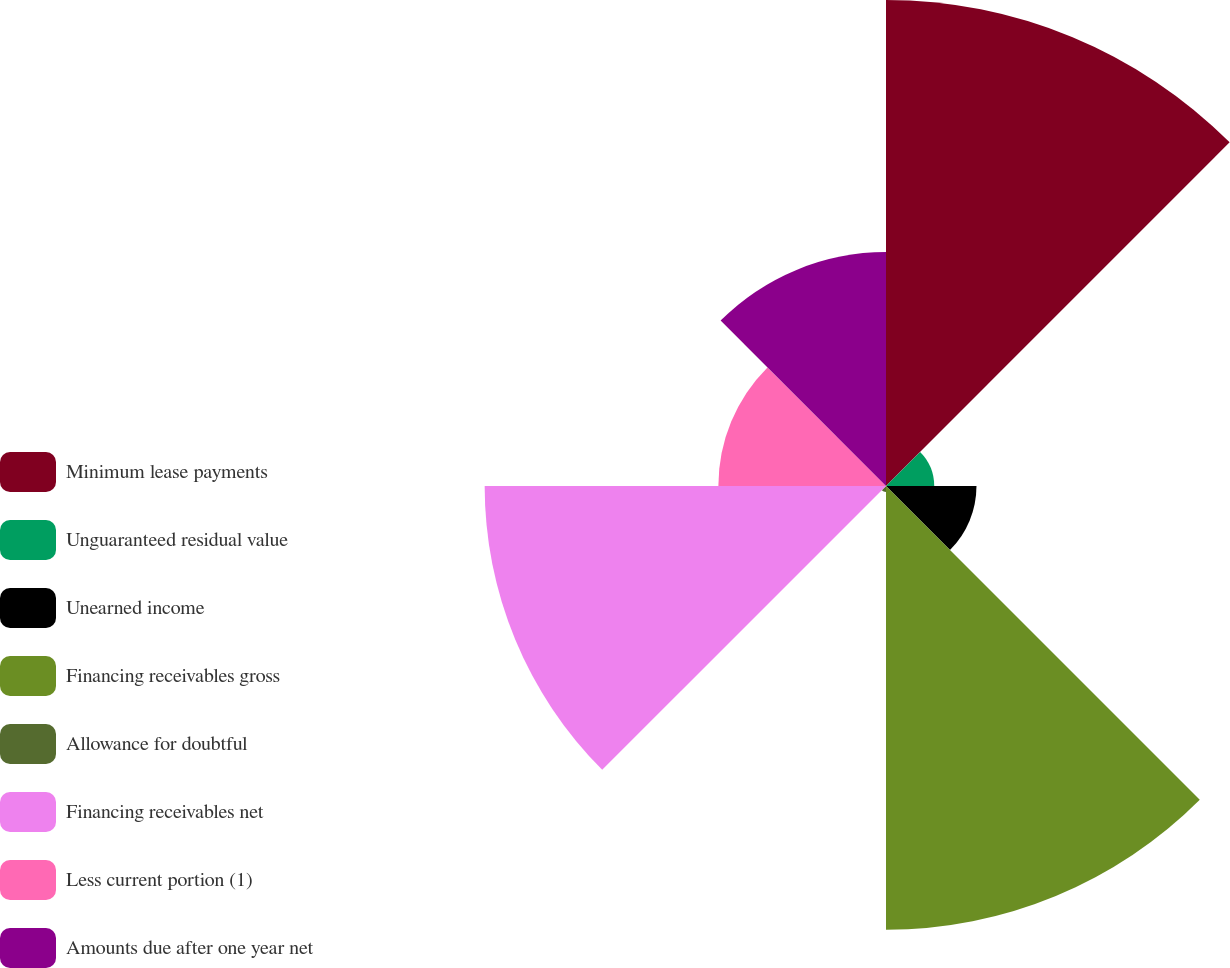Convert chart to OTSL. <chart><loc_0><loc_0><loc_500><loc_500><pie_chart><fcel>Minimum lease payments<fcel>Unguaranteed residual value<fcel>Unearned income<fcel>Financing receivables gross<fcel>Allowance for doubtful<fcel>Financing receivables net<fcel>Less current portion (1)<fcel>Amounts due after one year net<nl><fcel>25.89%<fcel>2.57%<fcel>4.82%<fcel>23.64%<fcel>0.32%<fcel>21.38%<fcel>8.93%<fcel>12.46%<nl></chart> 